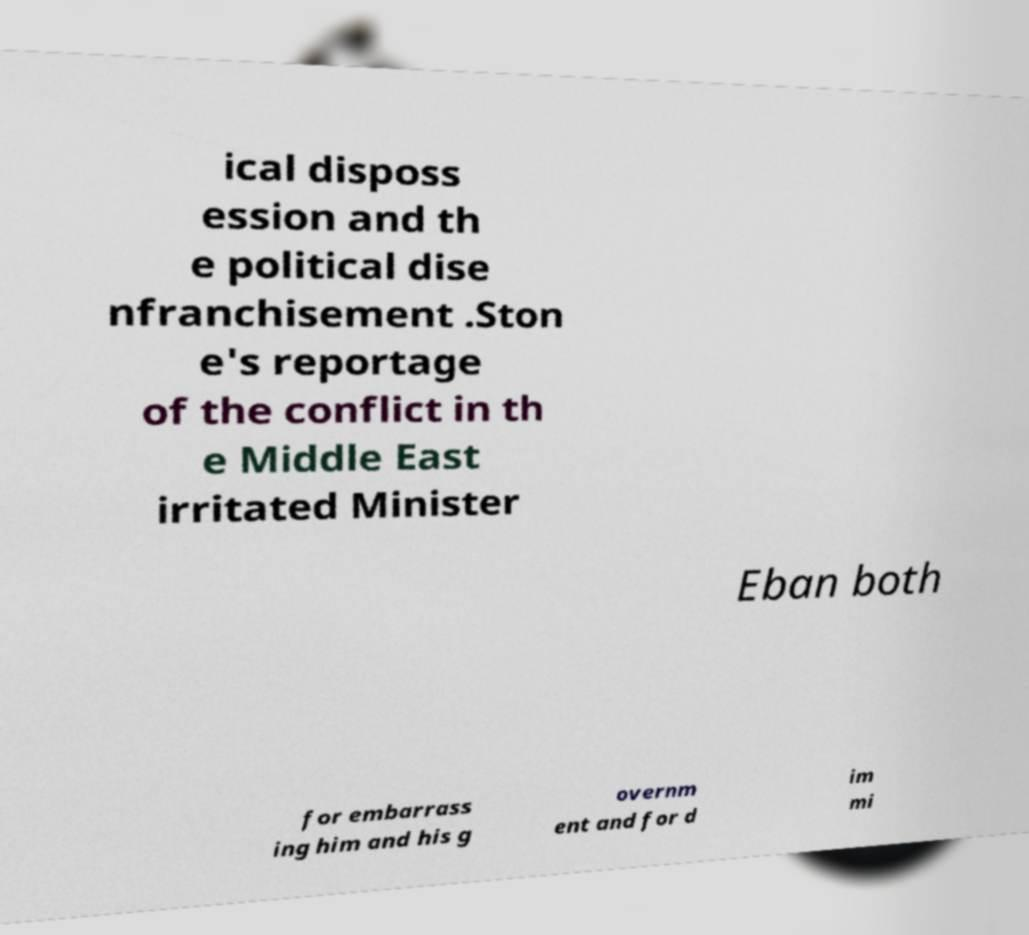What messages or text are displayed in this image? I need them in a readable, typed format. ical disposs ession and th e political dise nfranchisement .Ston e's reportage of the conflict in th e Middle East irritated Minister Eban both for embarrass ing him and his g overnm ent and for d im mi 